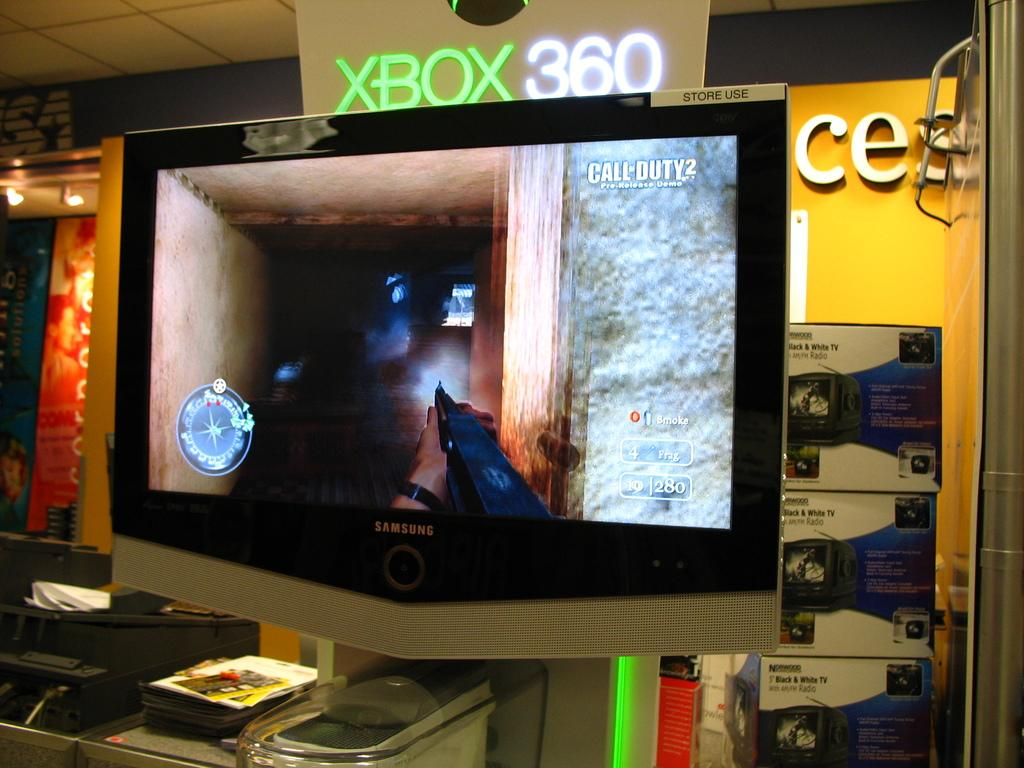<image>
Write a terse but informative summary of the picture. An Xbox 360 display table features a first-person shooter game. 